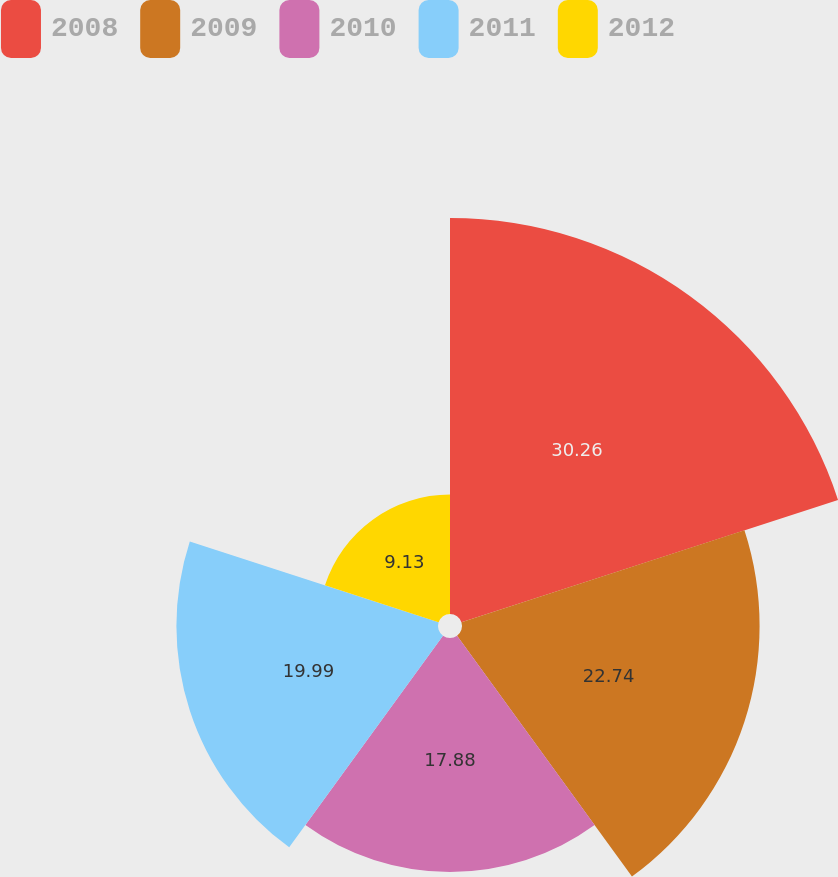Convert chart to OTSL. <chart><loc_0><loc_0><loc_500><loc_500><pie_chart><fcel>2008<fcel>2009<fcel>2010<fcel>2011<fcel>2012<nl><fcel>30.26%<fcel>22.74%<fcel>17.88%<fcel>19.99%<fcel>9.13%<nl></chart> 